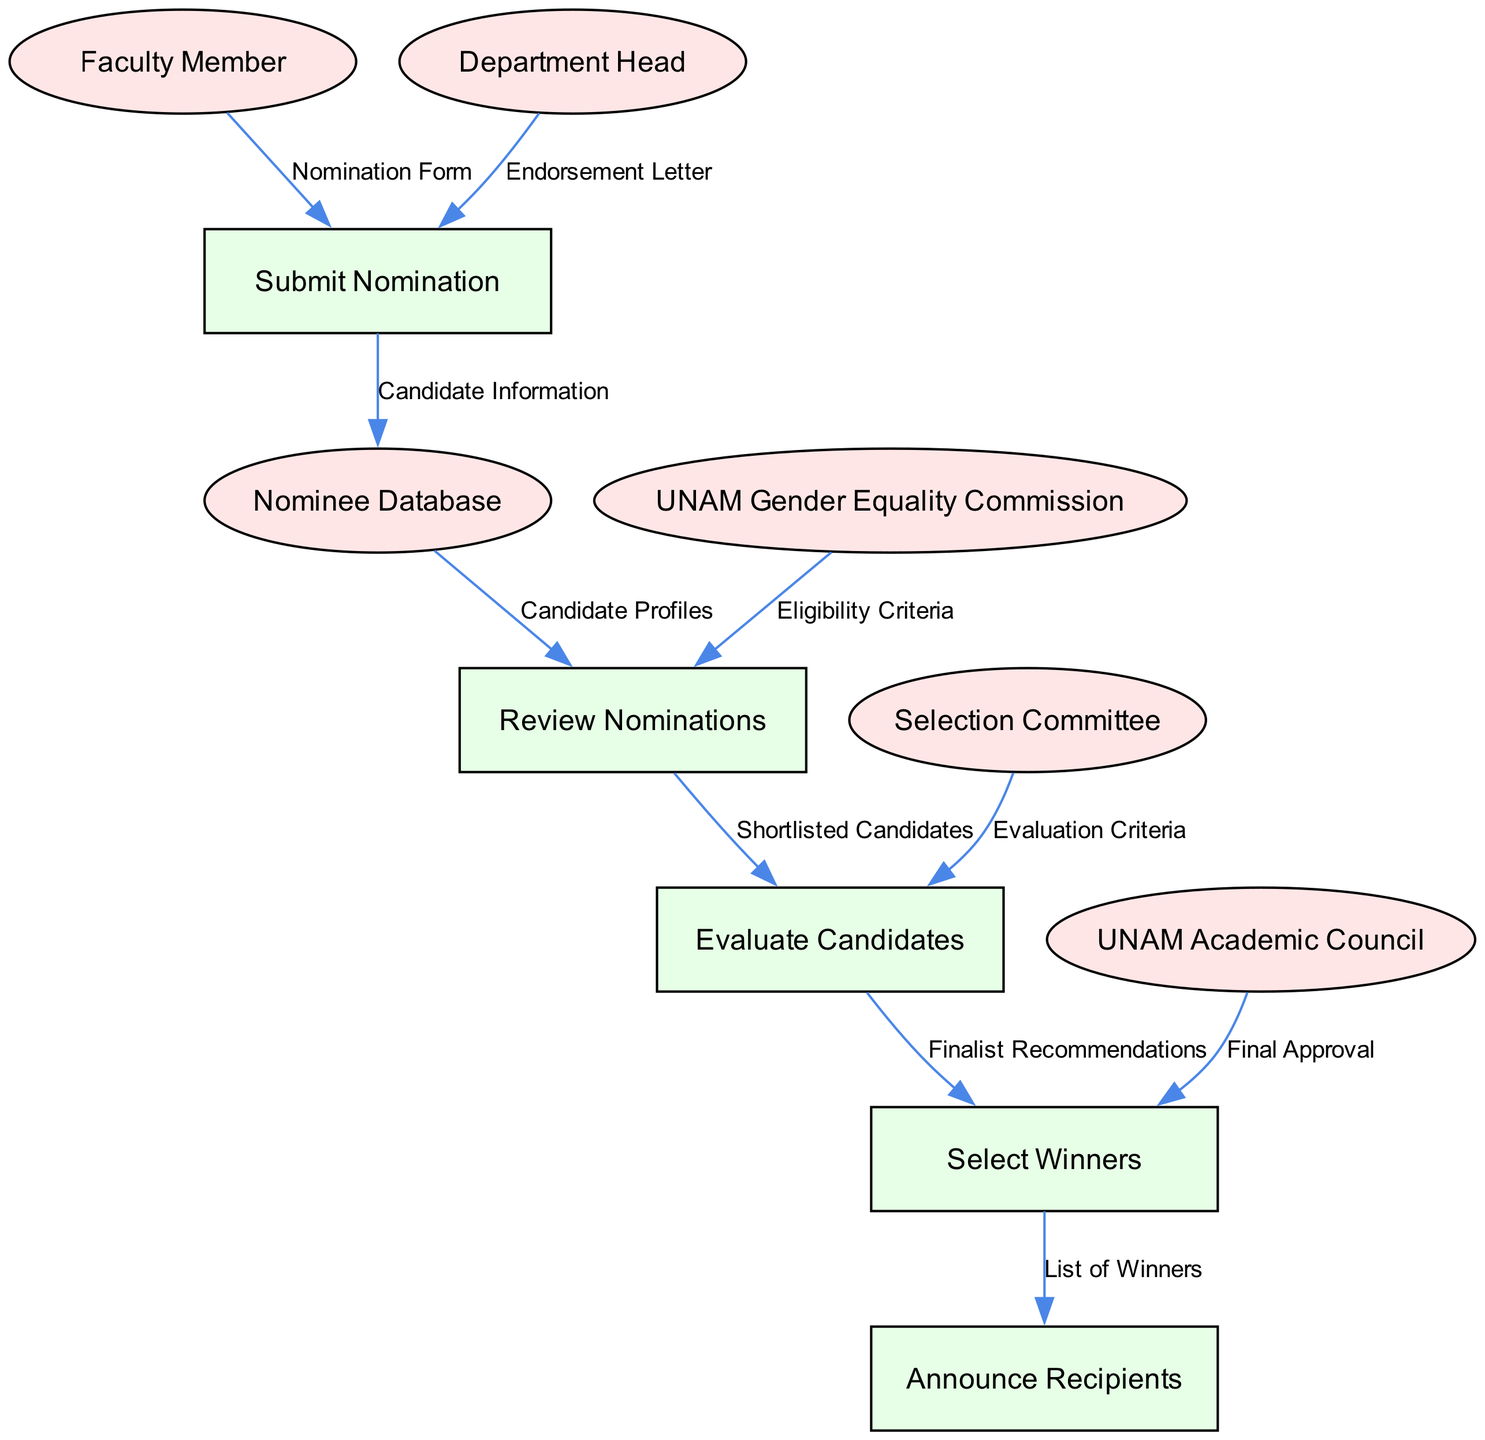What is the first process in the diagram? The first process displayed in the diagram is "Submit Nomination," which is indicated as the top node in the sequence of processes.
Answer: Submit Nomination Who submits the Nomination Form? The "Faculty Member" is responsible for submitting the Nomination Form, as per the flow directed from the Faculty Member to the Submit Nomination process.
Answer: Faculty Member How many main processes are there in the diagram? The diagram contains five main processes, which are visibly listed in sequence.
Answer: Five What is the last step in the nomination process? The last step is "Announce Recipients," as this is the final process that follows "Select Winners" in the flow.
Answer: Announce Recipients Which entity provides the Final Approval? The entity responsible for providing the Final Approval is the "UNAM Academic Council," as it connects directly to the Select Winners process.
Answer: UNAM Academic Council What data flows from "Nominee Database" to "Review Nominations"? The data that flows from the "Nominee Database" to "Review Nominations" is "Candidate Profiles," which signifies the information being reviewed.
Answer: Candidate Profiles How are candidates evaluated? Candidates are evaluated through the "Evaluate Candidates" process that follows the "Review Nominations" stage, based on the Shortlisted Candidates that were identified earlier.
Answer: Evaluate Candidates Which committee is involved in evaluating candidates? The committee involved in evaluating candidates is the "Selection Committee," which provides the Evaluation Criteria feeding into the Evaluate Candidates process.
Answer: Selection Committee What information does the Department Head provide? The Department Head provides an "Endorsement Letter," which is necessary for the submission of nominations at the Submit Nomination process.
Answer: Endorsement Letter 